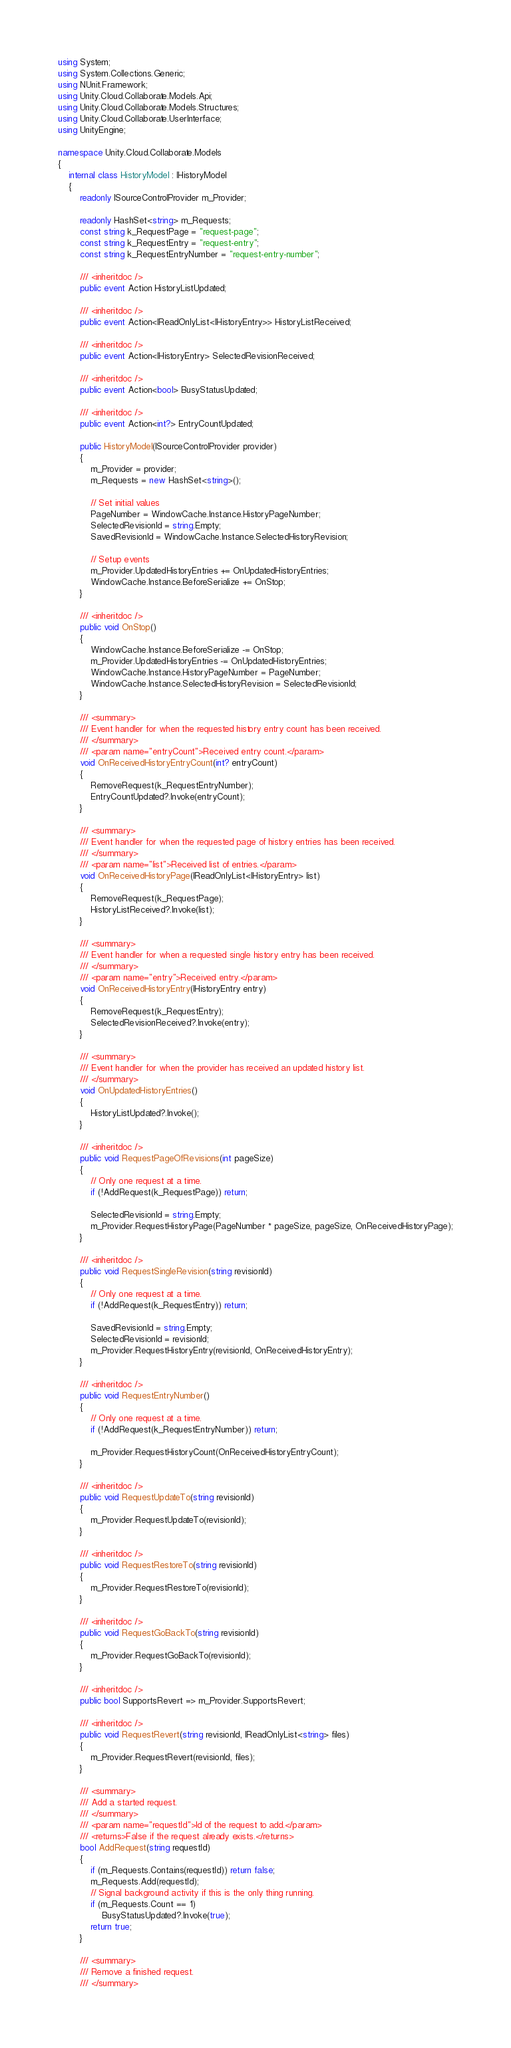<code> <loc_0><loc_0><loc_500><loc_500><_C#_>using System;
using System.Collections.Generic;
using NUnit.Framework;
using Unity.Cloud.Collaborate.Models.Api;
using Unity.Cloud.Collaborate.Models.Structures;
using Unity.Cloud.Collaborate.UserInterface;
using UnityEngine;

namespace Unity.Cloud.Collaborate.Models
{
    internal class HistoryModel : IHistoryModel
    {
        readonly ISourceControlProvider m_Provider;

        readonly HashSet<string> m_Requests;
        const string k_RequestPage = "request-page";
        const string k_RequestEntry = "request-entry";
        const string k_RequestEntryNumber = "request-entry-number";

        /// <inheritdoc />
        public event Action HistoryListUpdated;

        /// <inheritdoc />
        public event Action<IReadOnlyList<IHistoryEntry>> HistoryListReceived;

        /// <inheritdoc />
        public event Action<IHistoryEntry> SelectedRevisionReceived;

        /// <inheritdoc />
        public event Action<bool> BusyStatusUpdated;

        /// <inheritdoc />
        public event Action<int?> EntryCountUpdated;

        public HistoryModel(ISourceControlProvider provider)
        {
            m_Provider = provider;
            m_Requests = new HashSet<string>();

            // Set initial values
            PageNumber = WindowCache.Instance.HistoryPageNumber;
            SelectedRevisionId = string.Empty;
            SavedRevisionId = WindowCache.Instance.SelectedHistoryRevision;

            // Setup events
            m_Provider.UpdatedHistoryEntries += OnUpdatedHistoryEntries;
            WindowCache.Instance.BeforeSerialize += OnStop;
        }

        /// <inheritdoc />
        public void OnStop()
        {
            WindowCache.Instance.BeforeSerialize -= OnStop;
            m_Provider.UpdatedHistoryEntries -= OnUpdatedHistoryEntries;
            WindowCache.Instance.HistoryPageNumber = PageNumber;
            WindowCache.Instance.SelectedHistoryRevision = SelectedRevisionId;
        }

        /// <summary>
        /// Event handler for when the requested history entry count has been received.
        /// </summary>
        /// <param name="entryCount">Received entry count.</param>
        void OnReceivedHistoryEntryCount(int? entryCount)
        {
            RemoveRequest(k_RequestEntryNumber);
            EntryCountUpdated?.Invoke(entryCount);
        }

        /// <summary>
        /// Event handler for when the requested page of history entries has been received.
        /// </summary>
        /// <param name="list">Received list of entries.</param>
        void OnReceivedHistoryPage(IReadOnlyList<IHistoryEntry> list)
        {
            RemoveRequest(k_RequestPage);
            HistoryListReceived?.Invoke(list);
        }

        /// <summary>
        /// Event handler for when a requested single history entry has been received.
        /// </summary>
        /// <param name="entry">Received entry.</param>
        void OnReceivedHistoryEntry(IHistoryEntry entry)
        {
            RemoveRequest(k_RequestEntry);
            SelectedRevisionReceived?.Invoke(entry);
        }

        /// <summary>
        /// Event handler for when the provider has received an updated history list.
        /// </summary>
        void OnUpdatedHistoryEntries()
        {
            HistoryListUpdated?.Invoke();
        }

        /// <inheritdoc />
        public void RequestPageOfRevisions(int pageSize)
        {
            // Only one request at a time.
            if (!AddRequest(k_RequestPage)) return;

            SelectedRevisionId = string.Empty;
            m_Provider.RequestHistoryPage(PageNumber * pageSize, pageSize, OnReceivedHistoryPage);
        }

        /// <inheritdoc />
        public void RequestSingleRevision(string revisionId)
        {
            // Only one request at a time.
            if (!AddRequest(k_RequestEntry)) return;

            SavedRevisionId = string.Empty;
            SelectedRevisionId = revisionId;
            m_Provider.RequestHistoryEntry(revisionId, OnReceivedHistoryEntry);
        }

        /// <inheritdoc />
        public void RequestEntryNumber()
        {
            // Only one request at a time.
            if (!AddRequest(k_RequestEntryNumber)) return;

            m_Provider.RequestHistoryCount(OnReceivedHistoryEntryCount);
        }

        /// <inheritdoc />
        public void RequestUpdateTo(string revisionId)
        {
            m_Provider.RequestUpdateTo(revisionId);
        }

        /// <inheritdoc />
        public void RequestRestoreTo(string revisionId)
        {
            m_Provider.RequestRestoreTo(revisionId);
        }

        /// <inheritdoc />
        public void RequestGoBackTo(string revisionId)
        {
            m_Provider.RequestGoBackTo(revisionId);
        }

        /// <inheritdoc />
        public bool SupportsRevert => m_Provider.SupportsRevert;

        /// <inheritdoc />
        public void RequestRevert(string revisionId, IReadOnlyList<string> files)
        {
            m_Provider.RequestRevert(revisionId, files);
        }

        /// <summary>
        /// Add a started request.
        /// </summary>
        /// <param name="requestId">Id of the request to add.</param>
        /// <returns>False if the request already exists.</returns>
        bool AddRequest(string requestId)
        {
            if (m_Requests.Contains(requestId)) return false;
            m_Requests.Add(requestId);
            // Signal background activity if this is the only thing running.
            if (m_Requests.Count == 1)
                BusyStatusUpdated?.Invoke(true);
            return true;
        }

        /// <summary>
        /// Remove a finished request.
        /// </summary></code> 